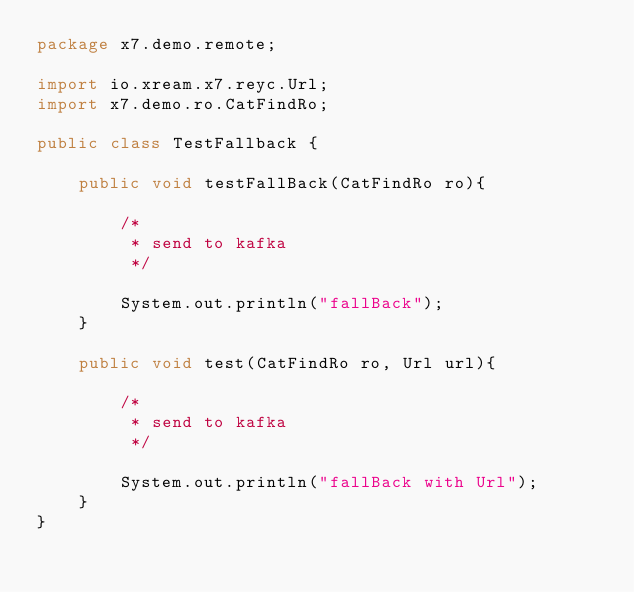<code> <loc_0><loc_0><loc_500><loc_500><_Java_>package x7.demo.remote;

import io.xream.x7.reyc.Url;
import x7.demo.ro.CatFindRo;

public class TestFallback {

    public void testFallBack(CatFindRo ro){

        /*
         * send to kafka
         */

        System.out.println("fallBack");
    }

    public void test(CatFindRo ro, Url url){

        /*
         * send to kafka
         */

        System.out.println("fallBack with Url");
    }
}
</code> 